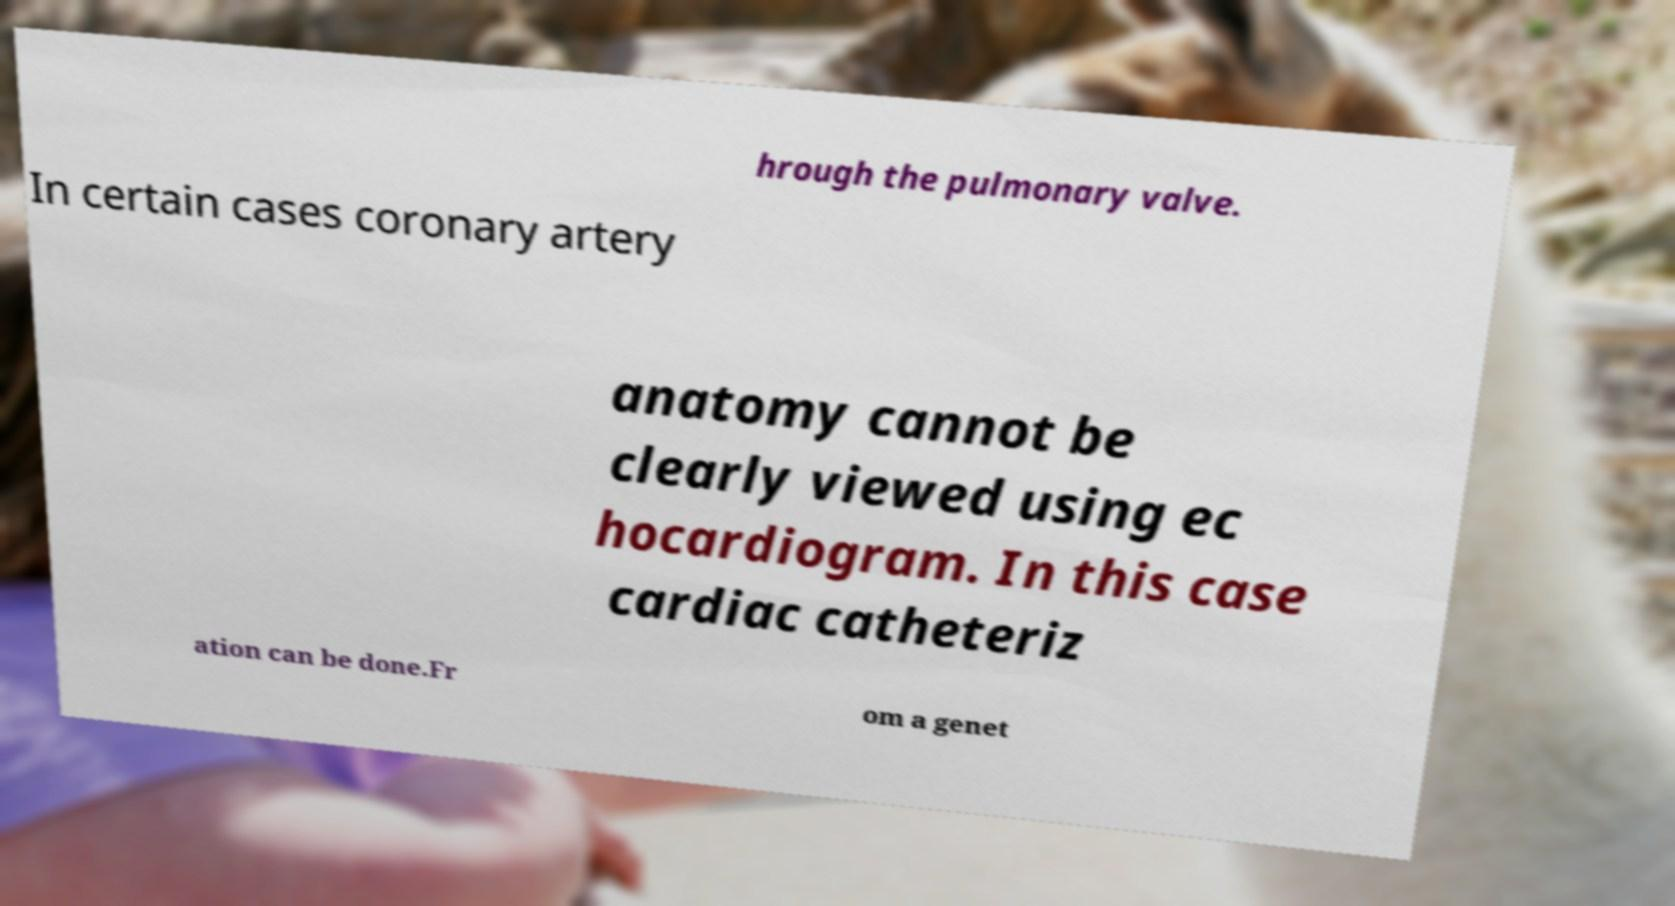There's text embedded in this image that I need extracted. Can you transcribe it verbatim? hrough the pulmonary valve. In certain cases coronary artery anatomy cannot be clearly viewed using ec hocardiogram. In this case cardiac catheteriz ation can be done.Fr om a genet 